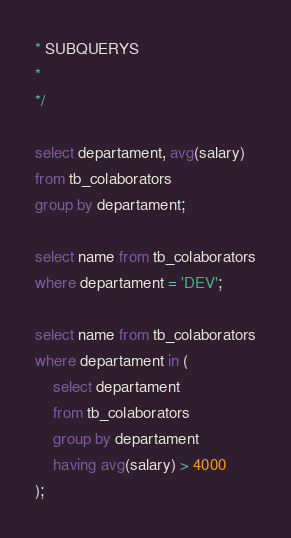Convert code to text. <code><loc_0><loc_0><loc_500><loc_500><_SQL_>* SUBQUERYS
*
*/

select departament, avg(salary)
from tb_colaborators
group by departament;

select name from tb_colaborators
where departament = 'DEV';

select name from tb_colaborators
where departament in (
    select departament
    from tb_colaborators
    group by departament
    having avg(salary) > 4000
);
</code> 